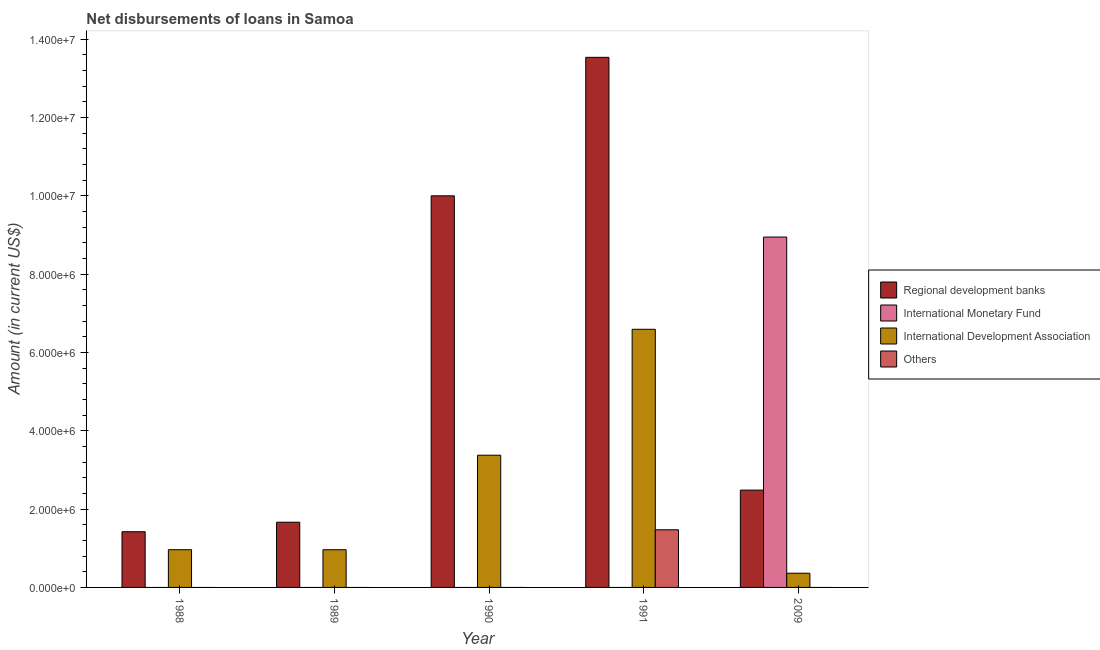Are the number of bars per tick equal to the number of legend labels?
Ensure brevity in your answer.  No. How many bars are there on the 4th tick from the right?
Your response must be concise. 2. What is the label of the 4th group of bars from the left?
Your response must be concise. 1991. Across all years, what is the maximum amount of loan disimbursed by other organisations?
Provide a succinct answer. 1.47e+06. Across all years, what is the minimum amount of loan disimbursed by regional development banks?
Keep it short and to the point. 1.42e+06. In which year was the amount of loan disimbursed by international development association maximum?
Your response must be concise. 1991. What is the total amount of loan disimbursed by international development association in the graph?
Provide a short and direct response. 1.23e+07. What is the difference between the amount of loan disimbursed by regional development banks in 1988 and that in 2009?
Make the answer very short. -1.06e+06. What is the difference between the amount of loan disimbursed by international monetary fund in 2009 and the amount of loan disimbursed by regional development banks in 1991?
Keep it short and to the point. 8.95e+06. What is the average amount of loan disimbursed by regional development banks per year?
Provide a short and direct response. 5.82e+06. In how many years, is the amount of loan disimbursed by international development association greater than 4800000 US$?
Your answer should be compact. 1. What is the ratio of the amount of loan disimbursed by international development association in 1989 to that in 1990?
Offer a very short reply. 0.28. Is the amount of loan disimbursed by regional development banks in 1989 less than that in 1990?
Your answer should be very brief. Yes. Is the difference between the amount of loan disimbursed by regional development banks in 1990 and 1991 greater than the difference between the amount of loan disimbursed by other organisations in 1990 and 1991?
Your response must be concise. No. What is the difference between the highest and the second highest amount of loan disimbursed by regional development banks?
Give a very brief answer. 3.54e+06. What is the difference between the highest and the lowest amount of loan disimbursed by other organisations?
Offer a very short reply. 1.47e+06. What is the difference between two consecutive major ticks on the Y-axis?
Give a very brief answer. 2.00e+06. Are the values on the major ticks of Y-axis written in scientific E-notation?
Your answer should be compact. Yes. Does the graph contain any zero values?
Offer a terse response. Yes. How are the legend labels stacked?
Give a very brief answer. Vertical. What is the title of the graph?
Keep it short and to the point. Net disbursements of loans in Samoa. Does "Sweden" appear as one of the legend labels in the graph?
Ensure brevity in your answer.  No. What is the label or title of the X-axis?
Ensure brevity in your answer.  Year. What is the Amount (in current US$) of Regional development banks in 1988?
Offer a terse response. 1.42e+06. What is the Amount (in current US$) in International Monetary Fund in 1988?
Your answer should be compact. 0. What is the Amount (in current US$) in International Development Association in 1988?
Offer a very short reply. 9.63e+05. What is the Amount (in current US$) in Regional development banks in 1989?
Ensure brevity in your answer.  1.66e+06. What is the Amount (in current US$) of International Development Association in 1989?
Offer a terse response. 9.62e+05. What is the Amount (in current US$) in Others in 1989?
Your answer should be very brief. 0. What is the Amount (in current US$) of Regional development banks in 1990?
Make the answer very short. 1.00e+07. What is the Amount (in current US$) of International Development Association in 1990?
Offer a very short reply. 3.38e+06. What is the Amount (in current US$) of Others in 1990?
Your answer should be very brief. 0. What is the Amount (in current US$) in Regional development banks in 1991?
Offer a very short reply. 1.35e+07. What is the Amount (in current US$) of International Development Association in 1991?
Your response must be concise. 6.59e+06. What is the Amount (in current US$) of Others in 1991?
Provide a succinct answer. 1.47e+06. What is the Amount (in current US$) of Regional development banks in 2009?
Offer a very short reply. 2.48e+06. What is the Amount (in current US$) of International Monetary Fund in 2009?
Offer a very short reply. 8.95e+06. What is the Amount (in current US$) of International Development Association in 2009?
Keep it short and to the point. 3.63e+05. Across all years, what is the maximum Amount (in current US$) of Regional development banks?
Keep it short and to the point. 1.35e+07. Across all years, what is the maximum Amount (in current US$) in International Monetary Fund?
Your answer should be very brief. 8.95e+06. Across all years, what is the maximum Amount (in current US$) in International Development Association?
Offer a terse response. 6.59e+06. Across all years, what is the maximum Amount (in current US$) of Others?
Keep it short and to the point. 1.47e+06. Across all years, what is the minimum Amount (in current US$) of Regional development banks?
Provide a succinct answer. 1.42e+06. Across all years, what is the minimum Amount (in current US$) of International Monetary Fund?
Make the answer very short. 0. Across all years, what is the minimum Amount (in current US$) of International Development Association?
Offer a terse response. 3.63e+05. Across all years, what is the minimum Amount (in current US$) in Others?
Your answer should be very brief. 0. What is the total Amount (in current US$) in Regional development banks in the graph?
Your answer should be very brief. 2.91e+07. What is the total Amount (in current US$) of International Monetary Fund in the graph?
Your answer should be very brief. 8.95e+06. What is the total Amount (in current US$) in International Development Association in the graph?
Your response must be concise. 1.23e+07. What is the total Amount (in current US$) in Others in the graph?
Your response must be concise. 1.47e+06. What is the difference between the Amount (in current US$) in Regional development banks in 1988 and that in 1989?
Provide a short and direct response. -2.43e+05. What is the difference between the Amount (in current US$) in International Development Association in 1988 and that in 1989?
Provide a succinct answer. 1000. What is the difference between the Amount (in current US$) in Regional development banks in 1988 and that in 1990?
Ensure brevity in your answer.  -8.58e+06. What is the difference between the Amount (in current US$) in International Development Association in 1988 and that in 1990?
Make the answer very short. -2.41e+06. What is the difference between the Amount (in current US$) of Regional development banks in 1988 and that in 1991?
Provide a short and direct response. -1.21e+07. What is the difference between the Amount (in current US$) in International Development Association in 1988 and that in 1991?
Your answer should be compact. -5.63e+06. What is the difference between the Amount (in current US$) of Regional development banks in 1988 and that in 2009?
Your answer should be very brief. -1.06e+06. What is the difference between the Amount (in current US$) of International Development Association in 1988 and that in 2009?
Offer a very short reply. 6.00e+05. What is the difference between the Amount (in current US$) in Regional development banks in 1989 and that in 1990?
Provide a succinct answer. -8.33e+06. What is the difference between the Amount (in current US$) of International Development Association in 1989 and that in 1990?
Keep it short and to the point. -2.41e+06. What is the difference between the Amount (in current US$) of Regional development banks in 1989 and that in 1991?
Your answer should be compact. -1.19e+07. What is the difference between the Amount (in current US$) of International Development Association in 1989 and that in 1991?
Offer a terse response. -5.63e+06. What is the difference between the Amount (in current US$) in Regional development banks in 1989 and that in 2009?
Provide a succinct answer. -8.20e+05. What is the difference between the Amount (in current US$) of International Development Association in 1989 and that in 2009?
Provide a short and direct response. 5.99e+05. What is the difference between the Amount (in current US$) of Regional development banks in 1990 and that in 1991?
Make the answer very short. -3.54e+06. What is the difference between the Amount (in current US$) in International Development Association in 1990 and that in 1991?
Provide a succinct answer. -3.22e+06. What is the difference between the Amount (in current US$) in Regional development banks in 1990 and that in 2009?
Your response must be concise. 7.51e+06. What is the difference between the Amount (in current US$) in International Development Association in 1990 and that in 2009?
Offer a very short reply. 3.01e+06. What is the difference between the Amount (in current US$) in Regional development banks in 1991 and that in 2009?
Give a very brief answer. 1.10e+07. What is the difference between the Amount (in current US$) in International Development Association in 1991 and that in 2009?
Offer a terse response. 6.23e+06. What is the difference between the Amount (in current US$) of Regional development banks in 1988 and the Amount (in current US$) of International Development Association in 1989?
Provide a succinct answer. 4.60e+05. What is the difference between the Amount (in current US$) of Regional development banks in 1988 and the Amount (in current US$) of International Development Association in 1990?
Keep it short and to the point. -1.95e+06. What is the difference between the Amount (in current US$) in Regional development banks in 1988 and the Amount (in current US$) in International Development Association in 1991?
Your answer should be very brief. -5.17e+06. What is the difference between the Amount (in current US$) of International Development Association in 1988 and the Amount (in current US$) of Others in 1991?
Your response must be concise. -5.09e+05. What is the difference between the Amount (in current US$) of Regional development banks in 1988 and the Amount (in current US$) of International Monetary Fund in 2009?
Your answer should be very brief. -7.52e+06. What is the difference between the Amount (in current US$) of Regional development banks in 1988 and the Amount (in current US$) of International Development Association in 2009?
Provide a short and direct response. 1.06e+06. What is the difference between the Amount (in current US$) of Regional development banks in 1989 and the Amount (in current US$) of International Development Association in 1990?
Ensure brevity in your answer.  -1.71e+06. What is the difference between the Amount (in current US$) in Regional development banks in 1989 and the Amount (in current US$) in International Development Association in 1991?
Your response must be concise. -4.93e+06. What is the difference between the Amount (in current US$) of Regional development banks in 1989 and the Amount (in current US$) of Others in 1991?
Your response must be concise. 1.93e+05. What is the difference between the Amount (in current US$) of International Development Association in 1989 and the Amount (in current US$) of Others in 1991?
Keep it short and to the point. -5.10e+05. What is the difference between the Amount (in current US$) of Regional development banks in 1989 and the Amount (in current US$) of International Monetary Fund in 2009?
Offer a terse response. -7.28e+06. What is the difference between the Amount (in current US$) of Regional development banks in 1989 and the Amount (in current US$) of International Development Association in 2009?
Your answer should be very brief. 1.30e+06. What is the difference between the Amount (in current US$) in Regional development banks in 1990 and the Amount (in current US$) in International Development Association in 1991?
Your answer should be very brief. 3.41e+06. What is the difference between the Amount (in current US$) of Regional development banks in 1990 and the Amount (in current US$) of Others in 1991?
Make the answer very short. 8.53e+06. What is the difference between the Amount (in current US$) of International Development Association in 1990 and the Amount (in current US$) of Others in 1991?
Give a very brief answer. 1.90e+06. What is the difference between the Amount (in current US$) in Regional development banks in 1990 and the Amount (in current US$) in International Monetary Fund in 2009?
Your answer should be very brief. 1.05e+06. What is the difference between the Amount (in current US$) in Regional development banks in 1990 and the Amount (in current US$) in International Development Association in 2009?
Make the answer very short. 9.64e+06. What is the difference between the Amount (in current US$) of Regional development banks in 1991 and the Amount (in current US$) of International Monetary Fund in 2009?
Your response must be concise. 4.59e+06. What is the difference between the Amount (in current US$) in Regional development banks in 1991 and the Amount (in current US$) in International Development Association in 2009?
Your response must be concise. 1.32e+07. What is the average Amount (in current US$) of Regional development banks per year?
Your response must be concise. 5.82e+06. What is the average Amount (in current US$) of International Monetary Fund per year?
Provide a short and direct response. 1.79e+06. What is the average Amount (in current US$) in International Development Association per year?
Give a very brief answer. 2.45e+06. What is the average Amount (in current US$) in Others per year?
Keep it short and to the point. 2.94e+05. In the year 1988, what is the difference between the Amount (in current US$) in Regional development banks and Amount (in current US$) in International Development Association?
Give a very brief answer. 4.59e+05. In the year 1989, what is the difference between the Amount (in current US$) in Regional development banks and Amount (in current US$) in International Development Association?
Provide a short and direct response. 7.03e+05. In the year 1990, what is the difference between the Amount (in current US$) of Regional development banks and Amount (in current US$) of International Development Association?
Provide a succinct answer. 6.62e+06. In the year 1991, what is the difference between the Amount (in current US$) in Regional development banks and Amount (in current US$) in International Development Association?
Provide a succinct answer. 6.94e+06. In the year 1991, what is the difference between the Amount (in current US$) of Regional development banks and Amount (in current US$) of Others?
Give a very brief answer. 1.21e+07. In the year 1991, what is the difference between the Amount (in current US$) in International Development Association and Amount (in current US$) in Others?
Keep it short and to the point. 5.12e+06. In the year 2009, what is the difference between the Amount (in current US$) of Regional development banks and Amount (in current US$) of International Monetary Fund?
Your answer should be very brief. -6.46e+06. In the year 2009, what is the difference between the Amount (in current US$) in Regional development banks and Amount (in current US$) in International Development Association?
Offer a very short reply. 2.12e+06. In the year 2009, what is the difference between the Amount (in current US$) of International Monetary Fund and Amount (in current US$) of International Development Association?
Provide a succinct answer. 8.58e+06. What is the ratio of the Amount (in current US$) of Regional development banks in 1988 to that in 1989?
Provide a short and direct response. 0.85. What is the ratio of the Amount (in current US$) of Regional development banks in 1988 to that in 1990?
Your answer should be compact. 0.14. What is the ratio of the Amount (in current US$) in International Development Association in 1988 to that in 1990?
Keep it short and to the point. 0.29. What is the ratio of the Amount (in current US$) in Regional development banks in 1988 to that in 1991?
Offer a terse response. 0.11. What is the ratio of the Amount (in current US$) in International Development Association in 1988 to that in 1991?
Provide a succinct answer. 0.15. What is the ratio of the Amount (in current US$) in Regional development banks in 1988 to that in 2009?
Ensure brevity in your answer.  0.57. What is the ratio of the Amount (in current US$) in International Development Association in 1988 to that in 2009?
Your answer should be very brief. 2.65. What is the ratio of the Amount (in current US$) in Regional development banks in 1989 to that in 1990?
Your answer should be compact. 0.17. What is the ratio of the Amount (in current US$) in International Development Association in 1989 to that in 1990?
Your answer should be very brief. 0.28. What is the ratio of the Amount (in current US$) in Regional development banks in 1989 to that in 1991?
Ensure brevity in your answer.  0.12. What is the ratio of the Amount (in current US$) of International Development Association in 1989 to that in 1991?
Keep it short and to the point. 0.15. What is the ratio of the Amount (in current US$) in Regional development banks in 1989 to that in 2009?
Keep it short and to the point. 0.67. What is the ratio of the Amount (in current US$) in International Development Association in 1989 to that in 2009?
Provide a short and direct response. 2.65. What is the ratio of the Amount (in current US$) in Regional development banks in 1990 to that in 1991?
Keep it short and to the point. 0.74. What is the ratio of the Amount (in current US$) of International Development Association in 1990 to that in 1991?
Provide a succinct answer. 0.51. What is the ratio of the Amount (in current US$) in Regional development banks in 1990 to that in 2009?
Offer a very short reply. 4.02. What is the ratio of the Amount (in current US$) in International Development Association in 1990 to that in 2009?
Your answer should be compact. 9.3. What is the ratio of the Amount (in current US$) in Regional development banks in 1991 to that in 2009?
Keep it short and to the point. 5.45. What is the ratio of the Amount (in current US$) in International Development Association in 1991 to that in 2009?
Offer a very short reply. 18.16. What is the difference between the highest and the second highest Amount (in current US$) in Regional development banks?
Provide a succinct answer. 3.54e+06. What is the difference between the highest and the second highest Amount (in current US$) of International Development Association?
Ensure brevity in your answer.  3.22e+06. What is the difference between the highest and the lowest Amount (in current US$) of Regional development banks?
Offer a very short reply. 1.21e+07. What is the difference between the highest and the lowest Amount (in current US$) in International Monetary Fund?
Make the answer very short. 8.95e+06. What is the difference between the highest and the lowest Amount (in current US$) of International Development Association?
Make the answer very short. 6.23e+06. What is the difference between the highest and the lowest Amount (in current US$) in Others?
Offer a terse response. 1.47e+06. 